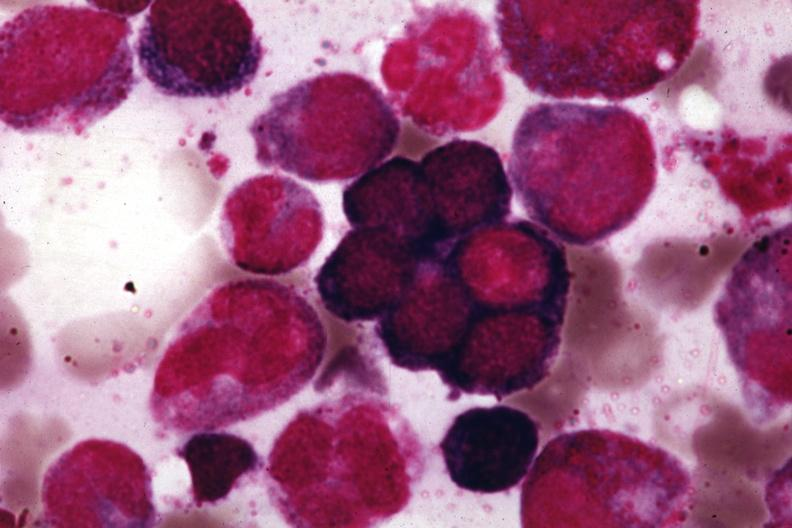s megaloblasts pernicious anemia present?
Answer the question using a single word or phrase. Yes 